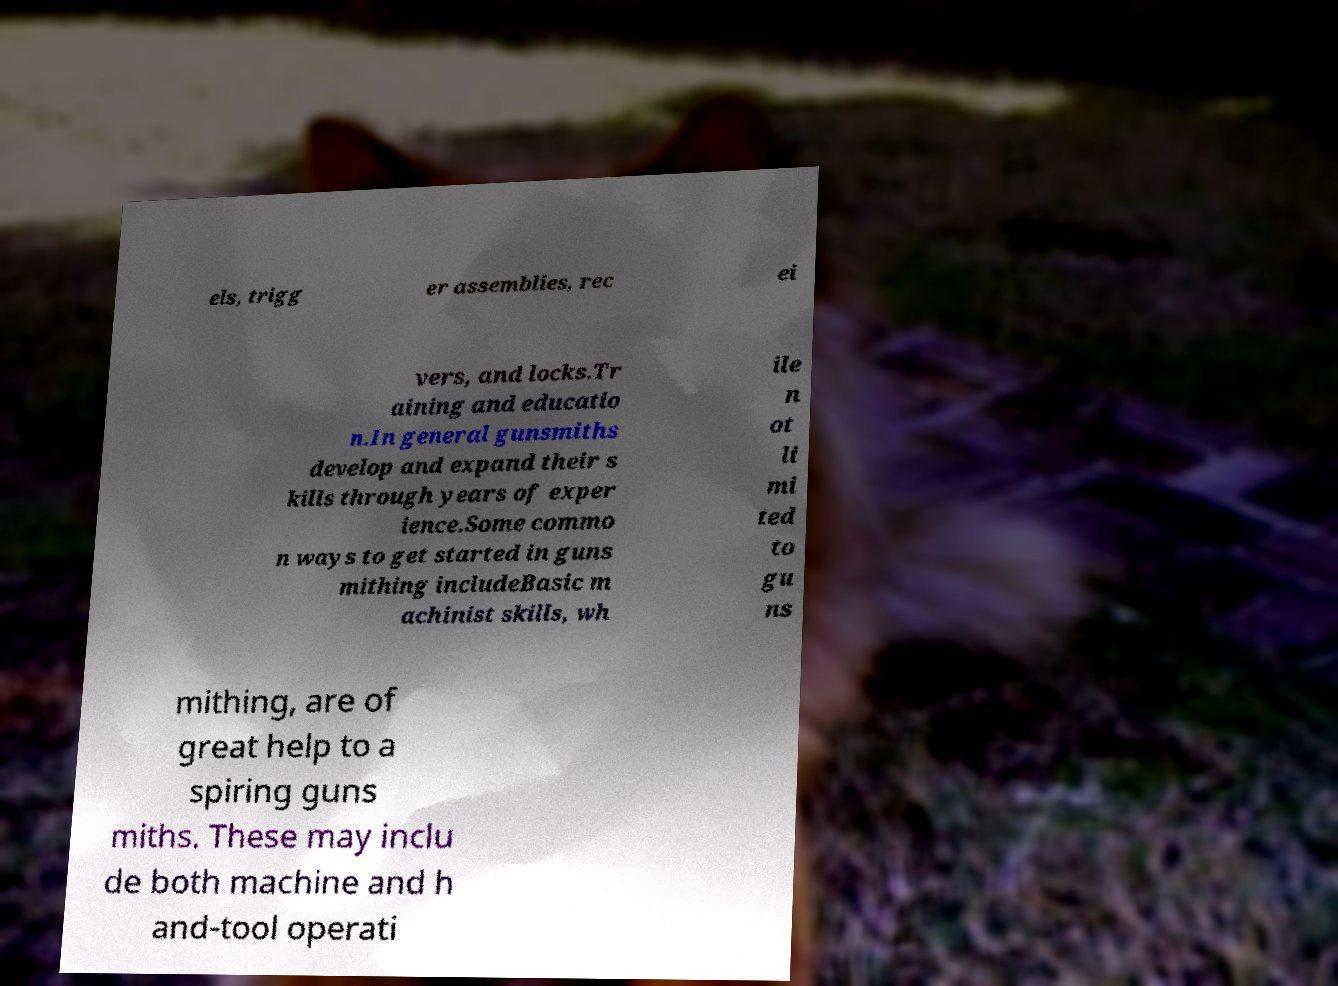Could you extract and type out the text from this image? els, trigg er assemblies, rec ei vers, and locks.Tr aining and educatio n.In general gunsmiths develop and expand their s kills through years of exper ience.Some commo n ways to get started in guns mithing includeBasic m achinist skills, wh ile n ot li mi ted to gu ns mithing, are of great help to a spiring guns miths. These may inclu de both machine and h and-tool operati 